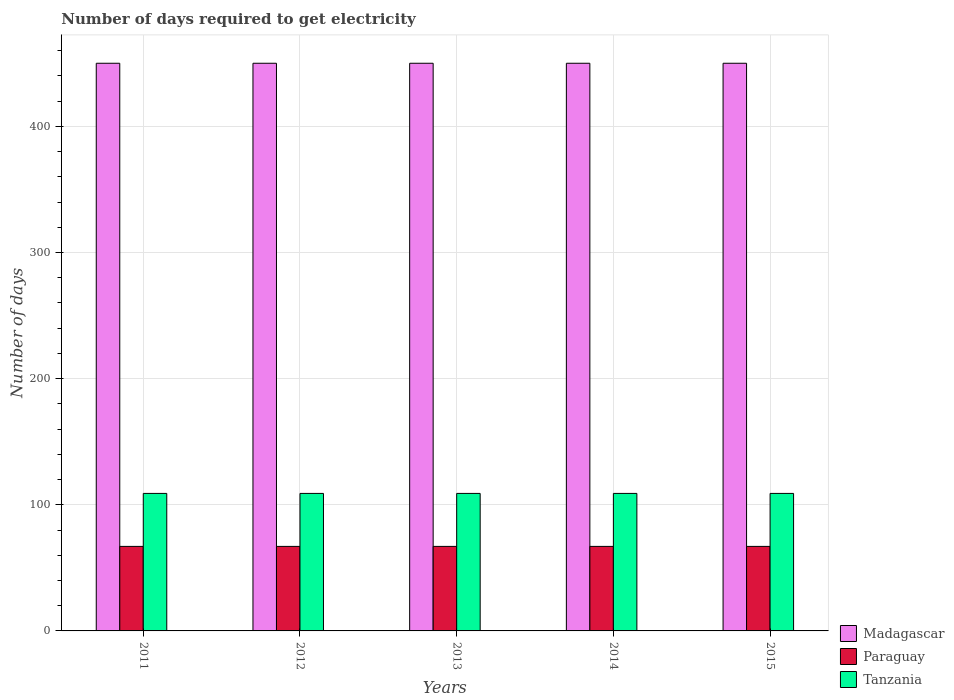How many bars are there on the 1st tick from the left?
Offer a very short reply. 3. How many bars are there on the 1st tick from the right?
Provide a succinct answer. 3. What is the label of the 4th group of bars from the left?
Your answer should be very brief. 2014. What is the number of days required to get electricity in in Paraguay in 2015?
Keep it short and to the point. 67. Across all years, what is the maximum number of days required to get electricity in in Tanzania?
Ensure brevity in your answer.  109. Across all years, what is the minimum number of days required to get electricity in in Paraguay?
Provide a succinct answer. 67. In which year was the number of days required to get electricity in in Paraguay maximum?
Your answer should be compact. 2011. In which year was the number of days required to get electricity in in Tanzania minimum?
Your answer should be very brief. 2011. What is the total number of days required to get electricity in in Paraguay in the graph?
Your answer should be very brief. 335. What is the difference between the number of days required to get electricity in in Tanzania in 2014 and that in 2015?
Offer a very short reply. 0. What is the difference between the number of days required to get electricity in in Tanzania in 2011 and the number of days required to get electricity in in Madagascar in 2015?
Your answer should be compact. -341. In the year 2015, what is the difference between the number of days required to get electricity in in Paraguay and number of days required to get electricity in in Tanzania?
Your response must be concise. -42. What is the ratio of the number of days required to get electricity in in Madagascar in 2011 to that in 2014?
Offer a terse response. 1. Is the number of days required to get electricity in in Paraguay in 2011 less than that in 2013?
Your answer should be very brief. No. Is the difference between the number of days required to get electricity in in Paraguay in 2012 and 2013 greater than the difference between the number of days required to get electricity in in Tanzania in 2012 and 2013?
Your response must be concise. No. What is the difference between the highest and the second highest number of days required to get electricity in in Tanzania?
Your answer should be compact. 0. What is the difference between the highest and the lowest number of days required to get electricity in in Paraguay?
Provide a short and direct response. 0. In how many years, is the number of days required to get electricity in in Madagascar greater than the average number of days required to get electricity in in Madagascar taken over all years?
Offer a terse response. 0. Is the sum of the number of days required to get electricity in in Madagascar in 2012 and 2014 greater than the maximum number of days required to get electricity in in Paraguay across all years?
Provide a short and direct response. Yes. What does the 2nd bar from the left in 2012 represents?
Make the answer very short. Paraguay. What does the 2nd bar from the right in 2015 represents?
Offer a terse response. Paraguay. How many bars are there?
Offer a very short reply. 15. Are all the bars in the graph horizontal?
Keep it short and to the point. No. How many years are there in the graph?
Provide a succinct answer. 5. Are the values on the major ticks of Y-axis written in scientific E-notation?
Keep it short and to the point. No. Does the graph contain any zero values?
Your answer should be very brief. No. How many legend labels are there?
Your answer should be compact. 3. What is the title of the graph?
Offer a terse response. Number of days required to get electricity. What is the label or title of the Y-axis?
Your answer should be very brief. Number of days. What is the Number of days of Madagascar in 2011?
Give a very brief answer. 450. What is the Number of days of Tanzania in 2011?
Offer a terse response. 109. What is the Number of days in Madagascar in 2012?
Your response must be concise. 450. What is the Number of days of Tanzania in 2012?
Make the answer very short. 109. What is the Number of days of Madagascar in 2013?
Offer a very short reply. 450. What is the Number of days of Tanzania in 2013?
Keep it short and to the point. 109. What is the Number of days of Madagascar in 2014?
Offer a very short reply. 450. What is the Number of days in Tanzania in 2014?
Your response must be concise. 109. What is the Number of days of Madagascar in 2015?
Your response must be concise. 450. What is the Number of days in Tanzania in 2015?
Make the answer very short. 109. Across all years, what is the maximum Number of days of Madagascar?
Give a very brief answer. 450. Across all years, what is the maximum Number of days in Tanzania?
Your answer should be very brief. 109. Across all years, what is the minimum Number of days of Madagascar?
Ensure brevity in your answer.  450. Across all years, what is the minimum Number of days in Paraguay?
Offer a very short reply. 67. Across all years, what is the minimum Number of days of Tanzania?
Provide a succinct answer. 109. What is the total Number of days in Madagascar in the graph?
Provide a short and direct response. 2250. What is the total Number of days of Paraguay in the graph?
Provide a succinct answer. 335. What is the total Number of days in Tanzania in the graph?
Ensure brevity in your answer.  545. What is the difference between the Number of days of Madagascar in 2011 and that in 2012?
Offer a very short reply. 0. What is the difference between the Number of days in Paraguay in 2011 and that in 2012?
Offer a very short reply. 0. What is the difference between the Number of days in Paraguay in 2011 and that in 2013?
Provide a succinct answer. 0. What is the difference between the Number of days of Paraguay in 2011 and that in 2015?
Provide a succinct answer. 0. What is the difference between the Number of days in Tanzania in 2012 and that in 2013?
Give a very brief answer. 0. What is the difference between the Number of days of Madagascar in 2012 and that in 2014?
Ensure brevity in your answer.  0. What is the difference between the Number of days of Tanzania in 2012 and that in 2014?
Provide a short and direct response. 0. What is the difference between the Number of days of Madagascar in 2012 and that in 2015?
Your answer should be compact. 0. What is the difference between the Number of days in Paraguay in 2012 and that in 2015?
Ensure brevity in your answer.  0. What is the difference between the Number of days of Tanzania in 2013 and that in 2014?
Make the answer very short. 0. What is the difference between the Number of days in Madagascar in 2013 and that in 2015?
Your answer should be compact. 0. What is the difference between the Number of days in Paraguay in 2013 and that in 2015?
Make the answer very short. 0. What is the difference between the Number of days in Tanzania in 2013 and that in 2015?
Your answer should be very brief. 0. What is the difference between the Number of days in Tanzania in 2014 and that in 2015?
Your response must be concise. 0. What is the difference between the Number of days in Madagascar in 2011 and the Number of days in Paraguay in 2012?
Offer a terse response. 383. What is the difference between the Number of days in Madagascar in 2011 and the Number of days in Tanzania in 2012?
Your answer should be very brief. 341. What is the difference between the Number of days in Paraguay in 2011 and the Number of days in Tanzania in 2012?
Give a very brief answer. -42. What is the difference between the Number of days of Madagascar in 2011 and the Number of days of Paraguay in 2013?
Provide a succinct answer. 383. What is the difference between the Number of days in Madagascar in 2011 and the Number of days in Tanzania in 2013?
Ensure brevity in your answer.  341. What is the difference between the Number of days in Paraguay in 2011 and the Number of days in Tanzania in 2013?
Your answer should be very brief. -42. What is the difference between the Number of days of Madagascar in 2011 and the Number of days of Paraguay in 2014?
Give a very brief answer. 383. What is the difference between the Number of days in Madagascar in 2011 and the Number of days in Tanzania in 2014?
Provide a short and direct response. 341. What is the difference between the Number of days of Paraguay in 2011 and the Number of days of Tanzania in 2014?
Ensure brevity in your answer.  -42. What is the difference between the Number of days of Madagascar in 2011 and the Number of days of Paraguay in 2015?
Keep it short and to the point. 383. What is the difference between the Number of days of Madagascar in 2011 and the Number of days of Tanzania in 2015?
Make the answer very short. 341. What is the difference between the Number of days in Paraguay in 2011 and the Number of days in Tanzania in 2015?
Ensure brevity in your answer.  -42. What is the difference between the Number of days of Madagascar in 2012 and the Number of days of Paraguay in 2013?
Provide a short and direct response. 383. What is the difference between the Number of days of Madagascar in 2012 and the Number of days of Tanzania in 2013?
Provide a short and direct response. 341. What is the difference between the Number of days in Paraguay in 2012 and the Number of days in Tanzania in 2013?
Give a very brief answer. -42. What is the difference between the Number of days of Madagascar in 2012 and the Number of days of Paraguay in 2014?
Offer a terse response. 383. What is the difference between the Number of days in Madagascar in 2012 and the Number of days in Tanzania in 2014?
Provide a succinct answer. 341. What is the difference between the Number of days of Paraguay in 2012 and the Number of days of Tanzania in 2014?
Make the answer very short. -42. What is the difference between the Number of days in Madagascar in 2012 and the Number of days in Paraguay in 2015?
Offer a very short reply. 383. What is the difference between the Number of days in Madagascar in 2012 and the Number of days in Tanzania in 2015?
Your answer should be very brief. 341. What is the difference between the Number of days in Paraguay in 2012 and the Number of days in Tanzania in 2015?
Keep it short and to the point. -42. What is the difference between the Number of days in Madagascar in 2013 and the Number of days in Paraguay in 2014?
Offer a very short reply. 383. What is the difference between the Number of days in Madagascar in 2013 and the Number of days in Tanzania in 2014?
Keep it short and to the point. 341. What is the difference between the Number of days of Paraguay in 2013 and the Number of days of Tanzania in 2014?
Provide a succinct answer. -42. What is the difference between the Number of days in Madagascar in 2013 and the Number of days in Paraguay in 2015?
Provide a short and direct response. 383. What is the difference between the Number of days in Madagascar in 2013 and the Number of days in Tanzania in 2015?
Provide a succinct answer. 341. What is the difference between the Number of days of Paraguay in 2013 and the Number of days of Tanzania in 2015?
Make the answer very short. -42. What is the difference between the Number of days of Madagascar in 2014 and the Number of days of Paraguay in 2015?
Give a very brief answer. 383. What is the difference between the Number of days of Madagascar in 2014 and the Number of days of Tanzania in 2015?
Your answer should be compact. 341. What is the difference between the Number of days in Paraguay in 2014 and the Number of days in Tanzania in 2015?
Give a very brief answer. -42. What is the average Number of days in Madagascar per year?
Your response must be concise. 450. What is the average Number of days of Paraguay per year?
Make the answer very short. 67. What is the average Number of days of Tanzania per year?
Your answer should be compact. 109. In the year 2011, what is the difference between the Number of days in Madagascar and Number of days in Paraguay?
Your answer should be very brief. 383. In the year 2011, what is the difference between the Number of days of Madagascar and Number of days of Tanzania?
Give a very brief answer. 341. In the year 2011, what is the difference between the Number of days of Paraguay and Number of days of Tanzania?
Give a very brief answer. -42. In the year 2012, what is the difference between the Number of days in Madagascar and Number of days in Paraguay?
Provide a succinct answer. 383. In the year 2012, what is the difference between the Number of days of Madagascar and Number of days of Tanzania?
Offer a terse response. 341. In the year 2012, what is the difference between the Number of days in Paraguay and Number of days in Tanzania?
Give a very brief answer. -42. In the year 2013, what is the difference between the Number of days in Madagascar and Number of days in Paraguay?
Provide a short and direct response. 383. In the year 2013, what is the difference between the Number of days of Madagascar and Number of days of Tanzania?
Keep it short and to the point. 341. In the year 2013, what is the difference between the Number of days in Paraguay and Number of days in Tanzania?
Offer a very short reply. -42. In the year 2014, what is the difference between the Number of days of Madagascar and Number of days of Paraguay?
Provide a succinct answer. 383. In the year 2014, what is the difference between the Number of days of Madagascar and Number of days of Tanzania?
Offer a very short reply. 341. In the year 2014, what is the difference between the Number of days in Paraguay and Number of days in Tanzania?
Offer a terse response. -42. In the year 2015, what is the difference between the Number of days in Madagascar and Number of days in Paraguay?
Ensure brevity in your answer.  383. In the year 2015, what is the difference between the Number of days of Madagascar and Number of days of Tanzania?
Make the answer very short. 341. In the year 2015, what is the difference between the Number of days in Paraguay and Number of days in Tanzania?
Offer a terse response. -42. What is the ratio of the Number of days in Madagascar in 2011 to that in 2012?
Keep it short and to the point. 1. What is the ratio of the Number of days of Tanzania in 2011 to that in 2012?
Offer a terse response. 1. What is the ratio of the Number of days of Madagascar in 2011 to that in 2013?
Give a very brief answer. 1. What is the ratio of the Number of days of Paraguay in 2011 to that in 2013?
Your response must be concise. 1. What is the ratio of the Number of days in Tanzania in 2011 to that in 2013?
Offer a very short reply. 1. What is the ratio of the Number of days in Madagascar in 2011 to that in 2014?
Make the answer very short. 1. What is the ratio of the Number of days of Madagascar in 2012 to that in 2013?
Ensure brevity in your answer.  1. What is the ratio of the Number of days of Paraguay in 2012 to that in 2013?
Provide a succinct answer. 1. What is the ratio of the Number of days in Tanzania in 2012 to that in 2013?
Your answer should be very brief. 1. What is the ratio of the Number of days in Madagascar in 2012 to that in 2014?
Your response must be concise. 1. What is the ratio of the Number of days of Paraguay in 2012 to that in 2014?
Make the answer very short. 1. What is the ratio of the Number of days of Madagascar in 2013 to that in 2014?
Your response must be concise. 1. What is the ratio of the Number of days in Paraguay in 2013 to that in 2014?
Your answer should be compact. 1. What is the ratio of the Number of days of Tanzania in 2013 to that in 2015?
Give a very brief answer. 1. What is the ratio of the Number of days in Madagascar in 2014 to that in 2015?
Provide a succinct answer. 1. What is the difference between the highest and the lowest Number of days of Paraguay?
Your answer should be compact. 0. 